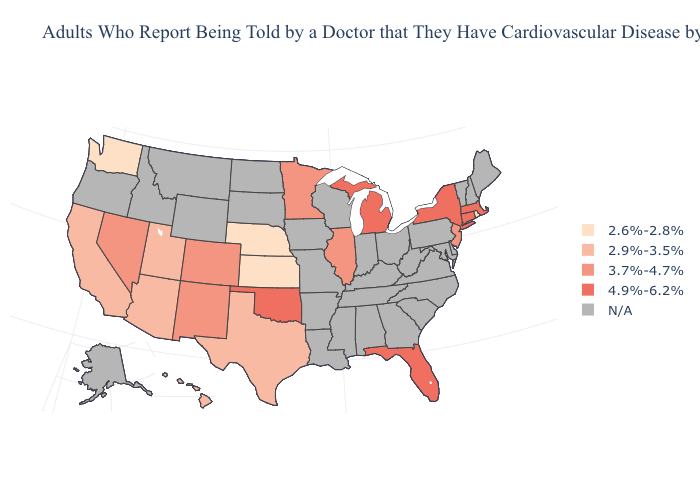Among the states that border Ohio , which have the highest value?
Short answer required. Michigan. Name the states that have a value in the range 4.9%-6.2%?
Short answer required. Connecticut, Florida, Massachusetts, Michigan, New York, Oklahoma. What is the lowest value in states that border Wyoming?
Short answer required. 2.6%-2.8%. Does Minnesota have the highest value in the USA?
Answer briefly. No. Among the states that border Arizona , does New Mexico have the highest value?
Give a very brief answer. Yes. Name the states that have a value in the range N/A?
Answer briefly. Alabama, Alaska, Arkansas, Delaware, Georgia, Idaho, Indiana, Iowa, Kentucky, Louisiana, Maine, Maryland, Mississippi, Missouri, Montana, New Hampshire, North Carolina, North Dakota, Ohio, Oregon, Pennsylvania, South Carolina, South Dakota, Tennessee, Vermont, Virginia, West Virginia, Wisconsin, Wyoming. Among the states that border Connecticut , which have the highest value?
Quick response, please. Massachusetts, New York. What is the value of Massachusetts?
Keep it brief. 4.9%-6.2%. Which states have the highest value in the USA?
Answer briefly. Connecticut, Florida, Massachusetts, Michigan, New York, Oklahoma. Name the states that have a value in the range N/A?
Write a very short answer. Alabama, Alaska, Arkansas, Delaware, Georgia, Idaho, Indiana, Iowa, Kentucky, Louisiana, Maine, Maryland, Mississippi, Missouri, Montana, New Hampshire, North Carolina, North Dakota, Ohio, Oregon, Pennsylvania, South Carolina, South Dakota, Tennessee, Vermont, Virginia, West Virginia, Wisconsin, Wyoming. Among the states that border Oregon , does Washington have the lowest value?
Keep it brief. Yes. Name the states that have a value in the range 2.6%-2.8%?
Be succinct. Kansas, Nebraska, Rhode Island, Washington. Which states have the highest value in the USA?
Keep it brief. Connecticut, Florida, Massachusetts, Michigan, New York, Oklahoma. 